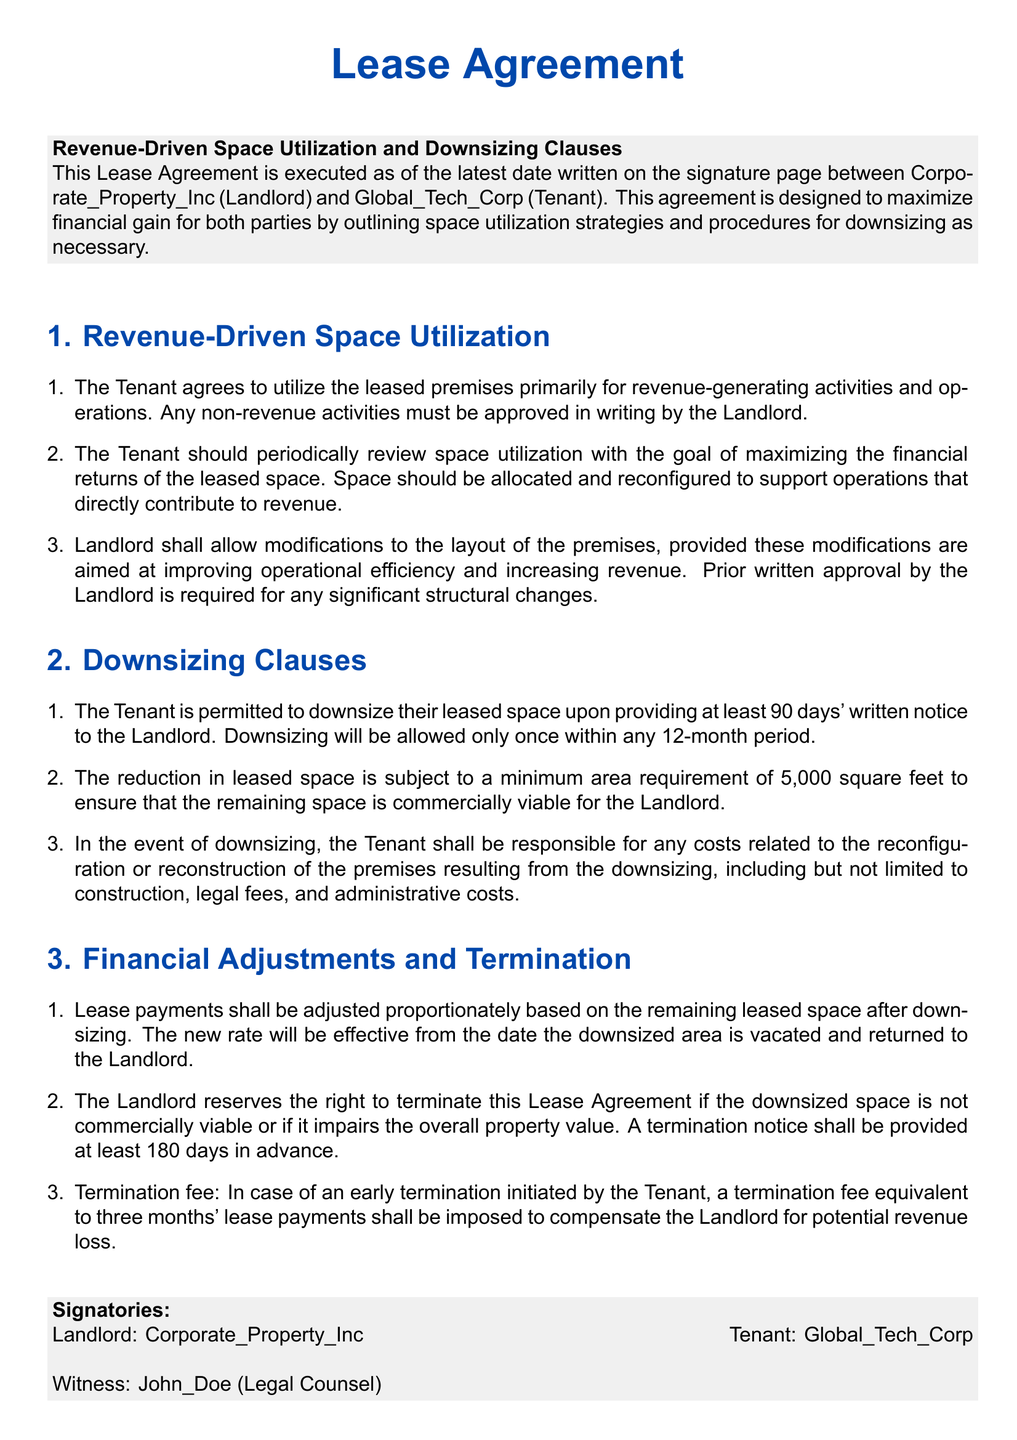What is the purpose of the Lease Agreement? The Lease Agreement is designed to maximize financial gain for both parties by outlining space utilization strategies and procedures for downsizing as necessary.
Answer: maximize financial gain Who is the Landlord in the agreement? The agreement specifies that Corporate_Property_Inc is the Landlord.
Answer: Corporate_Property_Inc What is the minimum area required for downsizing? The minimum area requirement for downsizing is stated as 5,000 square feet.
Answer: 5,000 square feet How much notice must the Tenant give before downsizing? The Tenant is required to provide at least 90 days' written notice prior to downsizing.
Answer: 90 days What happens if the downsized space is not commercially viable? If the downsized space is not commercially viable, the Landlord reserves the right to terminate the Lease Agreement.
Answer: terminate the Lease Agreement What is the penalty for early termination initiated by the Tenant? The penalty for early termination by the Tenant is a fee equivalent to three months' lease payments.
Answer: three months' lease payments What is the Tenant's responsibility during downsizing? The Tenant shall be responsible for any costs related to the reconfiguration or reconstruction of the premises resulting from the downsizing.
Answer: any costs related to reconfiguration How often can the Tenant downsize? The Tenant is allowed to downsize only once within any 12-month period.
Answer: once within any 12-month period What must modifications to the leased premises aim to improve? Modifications to the leased premises must aim to improve operational efficiency and increase revenue.
Answer: operational efficiency and increase revenue 